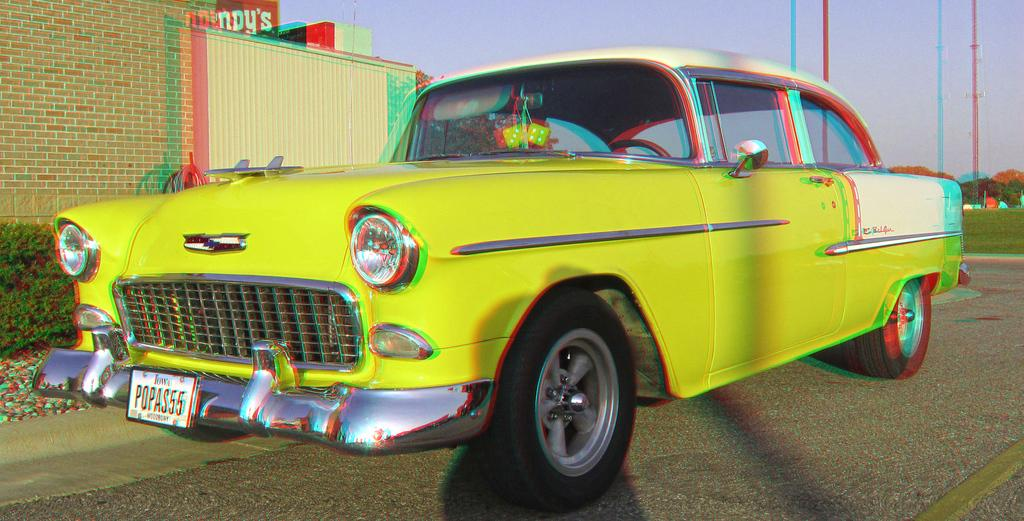What is on the road in the image? There is a car on the road in the image. What is located beside the car? There is a building beside the car. What type of vegetation is present on the ground? Plants are present on the ground. What else can be found on the ground? Stones are on the ground. What can be seen in the background of the image? There is grass, a pole, trees, and the sky visible in the background of the image. What type of collar is the pet wearing in the image? There is no pet present in the image, so there is no collar to be seen. 